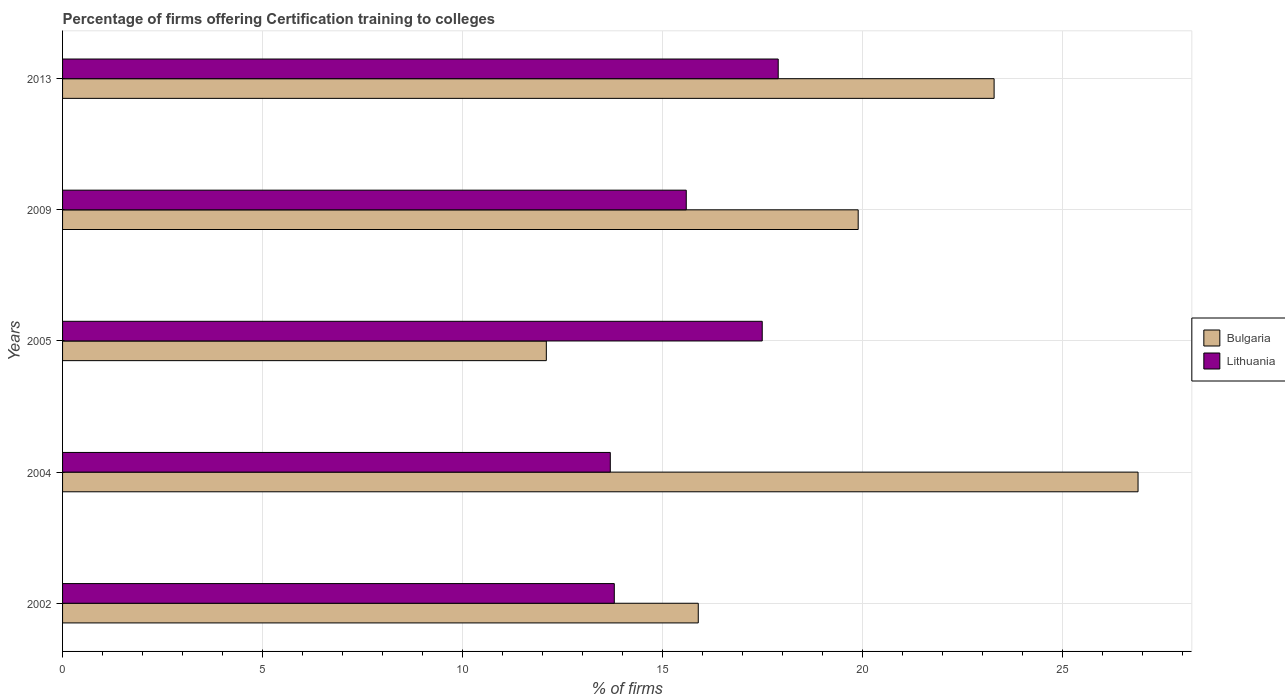How many groups of bars are there?
Provide a succinct answer. 5. What is the label of the 3rd group of bars from the top?
Your answer should be compact. 2005. In how many cases, is the number of bars for a given year not equal to the number of legend labels?
Give a very brief answer. 0. What is the total percentage of firms offering certification training to colleges in Bulgaria in the graph?
Offer a very short reply. 98.1. What is the difference between the percentage of firms offering certification training to colleges in Bulgaria in 2009 and that in 2013?
Your answer should be compact. -3.4. What is the difference between the percentage of firms offering certification training to colleges in Lithuania in 2009 and the percentage of firms offering certification training to colleges in Bulgaria in 2013?
Ensure brevity in your answer.  -7.7. What is the average percentage of firms offering certification training to colleges in Bulgaria per year?
Give a very brief answer. 19.62. In the year 2013, what is the difference between the percentage of firms offering certification training to colleges in Bulgaria and percentage of firms offering certification training to colleges in Lithuania?
Ensure brevity in your answer.  5.4. What is the ratio of the percentage of firms offering certification training to colleges in Bulgaria in 2009 to that in 2013?
Give a very brief answer. 0.85. Is the percentage of firms offering certification training to colleges in Lithuania in 2005 less than that in 2009?
Provide a short and direct response. No. Is the difference between the percentage of firms offering certification training to colleges in Bulgaria in 2004 and 2009 greater than the difference between the percentage of firms offering certification training to colleges in Lithuania in 2004 and 2009?
Give a very brief answer. Yes. What is the difference between the highest and the second highest percentage of firms offering certification training to colleges in Lithuania?
Provide a short and direct response. 0.4. What is the difference between the highest and the lowest percentage of firms offering certification training to colleges in Bulgaria?
Offer a terse response. 14.8. What does the 2nd bar from the bottom in 2013 represents?
Provide a succinct answer. Lithuania. How many years are there in the graph?
Offer a terse response. 5. Does the graph contain grids?
Provide a succinct answer. Yes. Where does the legend appear in the graph?
Offer a terse response. Center right. How are the legend labels stacked?
Offer a very short reply. Vertical. What is the title of the graph?
Offer a very short reply. Percentage of firms offering Certification training to colleges. What is the label or title of the X-axis?
Your answer should be compact. % of firms. What is the % of firms in Lithuania in 2002?
Ensure brevity in your answer.  13.8. What is the % of firms of Bulgaria in 2004?
Ensure brevity in your answer.  26.9. What is the % of firms of Lithuania in 2004?
Ensure brevity in your answer.  13.7. What is the % of firms in Lithuania in 2005?
Your answer should be very brief. 17.5. What is the % of firms of Bulgaria in 2009?
Your response must be concise. 19.9. What is the % of firms of Lithuania in 2009?
Offer a terse response. 15.6. What is the % of firms of Bulgaria in 2013?
Your response must be concise. 23.3. What is the % of firms of Lithuania in 2013?
Your answer should be compact. 17.9. Across all years, what is the maximum % of firms of Bulgaria?
Ensure brevity in your answer.  26.9. Across all years, what is the maximum % of firms of Lithuania?
Make the answer very short. 17.9. Across all years, what is the minimum % of firms in Bulgaria?
Give a very brief answer. 12.1. What is the total % of firms in Bulgaria in the graph?
Ensure brevity in your answer.  98.1. What is the total % of firms of Lithuania in the graph?
Offer a terse response. 78.5. What is the difference between the % of firms in Bulgaria in 2002 and that in 2005?
Keep it short and to the point. 3.8. What is the difference between the % of firms in Bulgaria in 2002 and that in 2009?
Give a very brief answer. -4. What is the difference between the % of firms of Lithuania in 2002 and that in 2013?
Keep it short and to the point. -4.1. What is the difference between the % of firms of Bulgaria in 2004 and that in 2005?
Give a very brief answer. 14.8. What is the difference between the % of firms in Lithuania in 2004 and that in 2005?
Ensure brevity in your answer.  -3.8. What is the difference between the % of firms in Lithuania in 2004 and that in 2009?
Ensure brevity in your answer.  -1.9. What is the difference between the % of firms in Lithuania in 2004 and that in 2013?
Keep it short and to the point. -4.2. What is the difference between the % of firms in Bulgaria in 2005 and that in 2009?
Provide a succinct answer. -7.8. What is the difference between the % of firms of Bulgaria in 2005 and that in 2013?
Ensure brevity in your answer.  -11.2. What is the difference between the % of firms of Bulgaria in 2009 and that in 2013?
Give a very brief answer. -3.4. What is the difference between the % of firms in Lithuania in 2009 and that in 2013?
Your answer should be very brief. -2.3. What is the difference between the % of firms in Bulgaria in 2002 and the % of firms in Lithuania in 2013?
Provide a succinct answer. -2. What is the difference between the % of firms in Bulgaria in 2004 and the % of firms in Lithuania in 2005?
Keep it short and to the point. 9.4. What is the difference between the % of firms in Bulgaria in 2004 and the % of firms in Lithuania in 2009?
Your answer should be compact. 11.3. What is the difference between the % of firms in Bulgaria in 2005 and the % of firms in Lithuania in 2009?
Ensure brevity in your answer.  -3.5. What is the average % of firms of Bulgaria per year?
Your response must be concise. 19.62. In the year 2004, what is the difference between the % of firms of Bulgaria and % of firms of Lithuania?
Your answer should be compact. 13.2. What is the ratio of the % of firms of Bulgaria in 2002 to that in 2004?
Your response must be concise. 0.59. What is the ratio of the % of firms of Lithuania in 2002 to that in 2004?
Ensure brevity in your answer.  1.01. What is the ratio of the % of firms of Bulgaria in 2002 to that in 2005?
Your answer should be very brief. 1.31. What is the ratio of the % of firms in Lithuania in 2002 to that in 2005?
Offer a terse response. 0.79. What is the ratio of the % of firms in Bulgaria in 2002 to that in 2009?
Provide a short and direct response. 0.8. What is the ratio of the % of firms in Lithuania in 2002 to that in 2009?
Offer a terse response. 0.88. What is the ratio of the % of firms in Bulgaria in 2002 to that in 2013?
Give a very brief answer. 0.68. What is the ratio of the % of firms of Lithuania in 2002 to that in 2013?
Your answer should be very brief. 0.77. What is the ratio of the % of firms of Bulgaria in 2004 to that in 2005?
Ensure brevity in your answer.  2.22. What is the ratio of the % of firms of Lithuania in 2004 to that in 2005?
Provide a short and direct response. 0.78. What is the ratio of the % of firms of Bulgaria in 2004 to that in 2009?
Your answer should be compact. 1.35. What is the ratio of the % of firms of Lithuania in 2004 to that in 2009?
Keep it short and to the point. 0.88. What is the ratio of the % of firms in Bulgaria in 2004 to that in 2013?
Offer a terse response. 1.15. What is the ratio of the % of firms of Lithuania in 2004 to that in 2013?
Offer a very short reply. 0.77. What is the ratio of the % of firms of Bulgaria in 2005 to that in 2009?
Keep it short and to the point. 0.61. What is the ratio of the % of firms of Lithuania in 2005 to that in 2009?
Give a very brief answer. 1.12. What is the ratio of the % of firms in Bulgaria in 2005 to that in 2013?
Ensure brevity in your answer.  0.52. What is the ratio of the % of firms of Lithuania in 2005 to that in 2013?
Your response must be concise. 0.98. What is the ratio of the % of firms of Bulgaria in 2009 to that in 2013?
Your answer should be very brief. 0.85. What is the ratio of the % of firms of Lithuania in 2009 to that in 2013?
Give a very brief answer. 0.87. What is the difference between the highest and the lowest % of firms of Bulgaria?
Make the answer very short. 14.8. What is the difference between the highest and the lowest % of firms of Lithuania?
Offer a terse response. 4.2. 